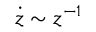Convert formula to latex. <formula><loc_0><loc_0><loc_500><loc_500>\dot { z } \sim z ^ { - 1 }</formula> 